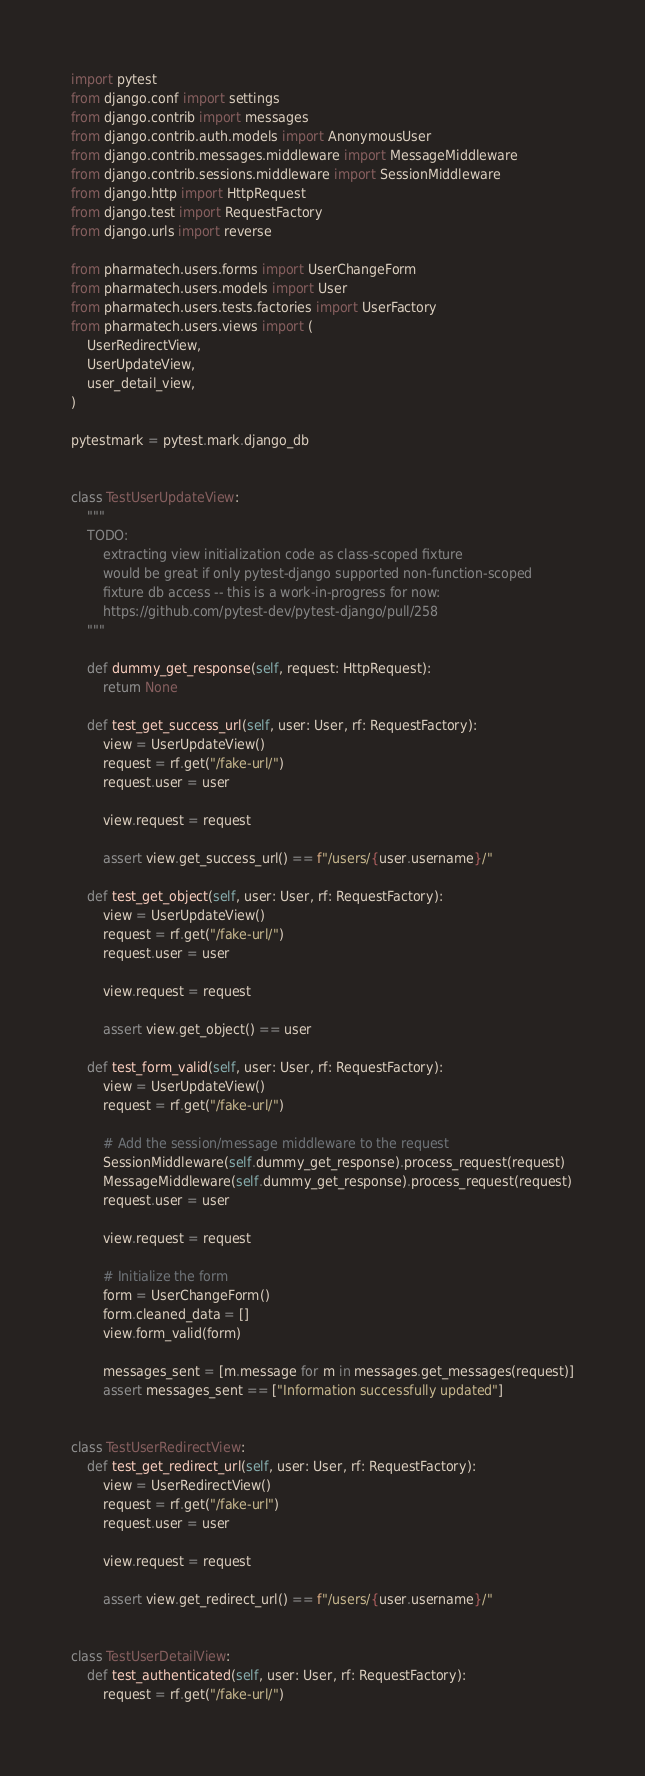Convert code to text. <code><loc_0><loc_0><loc_500><loc_500><_Python_>import pytest
from django.conf import settings
from django.contrib import messages
from django.contrib.auth.models import AnonymousUser
from django.contrib.messages.middleware import MessageMiddleware
from django.contrib.sessions.middleware import SessionMiddleware
from django.http import HttpRequest
from django.test import RequestFactory
from django.urls import reverse

from pharmatech.users.forms import UserChangeForm
from pharmatech.users.models import User
from pharmatech.users.tests.factories import UserFactory
from pharmatech.users.views import (
    UserRedirectView,
    UserUpdateView,
    user_detail_view,
)

pytestmark = pytest.mark.django_db


class TestUserUpdateView:
    """
    TODO:
        extracting view initialization code as class-scoped fixture
        would be great if only pytest-django supported non-function-scoped
        fixture db access -- this is a work-in-progress for now:
        https://github.com/pytest-dev/pytest-django/pull/258
    """

    def dummy_get_response(self, request: HttpRequest):
        return None

    def test_get_success_url(self, user: User, rf: RequestFactory):
        view = UserUpdateView()
        request = rf.get("/fake-url/")
        request.user = user

        view.request = request

        assert view.get_success_url() == f"/users/{user.username}/"

    def test_get_object(self, user: User, rf: RequestFactory):
        view = UserUpdateView()
        request = rf.get("/fake-url/")
        request.user = user

        view.request = request

        assert view.get_object() == user

    def test_form_valid(self, user: User, rf: RequestFactory):
        view = UserUpdateView()
        request = rf.get("/fake-url/")

        # Add the session/message middleware to the request
        SessionMiddleware(self.dummy_get_response).process_request(request)
        MessageMiddleware(self.dummy_get_response).process_request(request)
        request.user = user

        view.request = request

        # Initialize the form
        form = UserChangeForm()
        form.cleaned_data = []
        view.form_valid(form)

        messages_sent = [m.message for m in messages.get_messages(request)]
        assert messages_sent == ["Information successfully updated"]


class TestUserRedirectView:
    def test_get_redirect_url(self, user: User, rf: RequestFactory):
        view = UserRedirectView()
        request = rf.get("/fake-url")
        request.user = user

        view.request = request

        assert view.get_redirect_url() == f"/users/{user.username}/"


class TestUserDetailView:
    def test_authenticated(self, user: User, rf: RequestFactory):
        request = rf.get("/fake-url/")</code> 